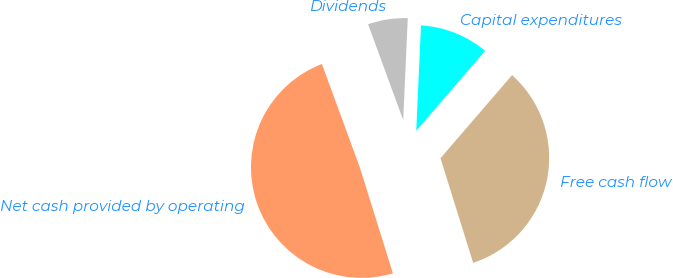Convert chart. <chart><loc_0><loc_0><loc_500><loc_500><pie_chart><fcel>Free cash flow<fcel>Capital expenditures<fcel>Dividends<fcel>Net cash provided by operating<nl><fcel>33.86%<fcel>10.6%<fcel>6.31%<fcel>49.22%<nl></chart> 